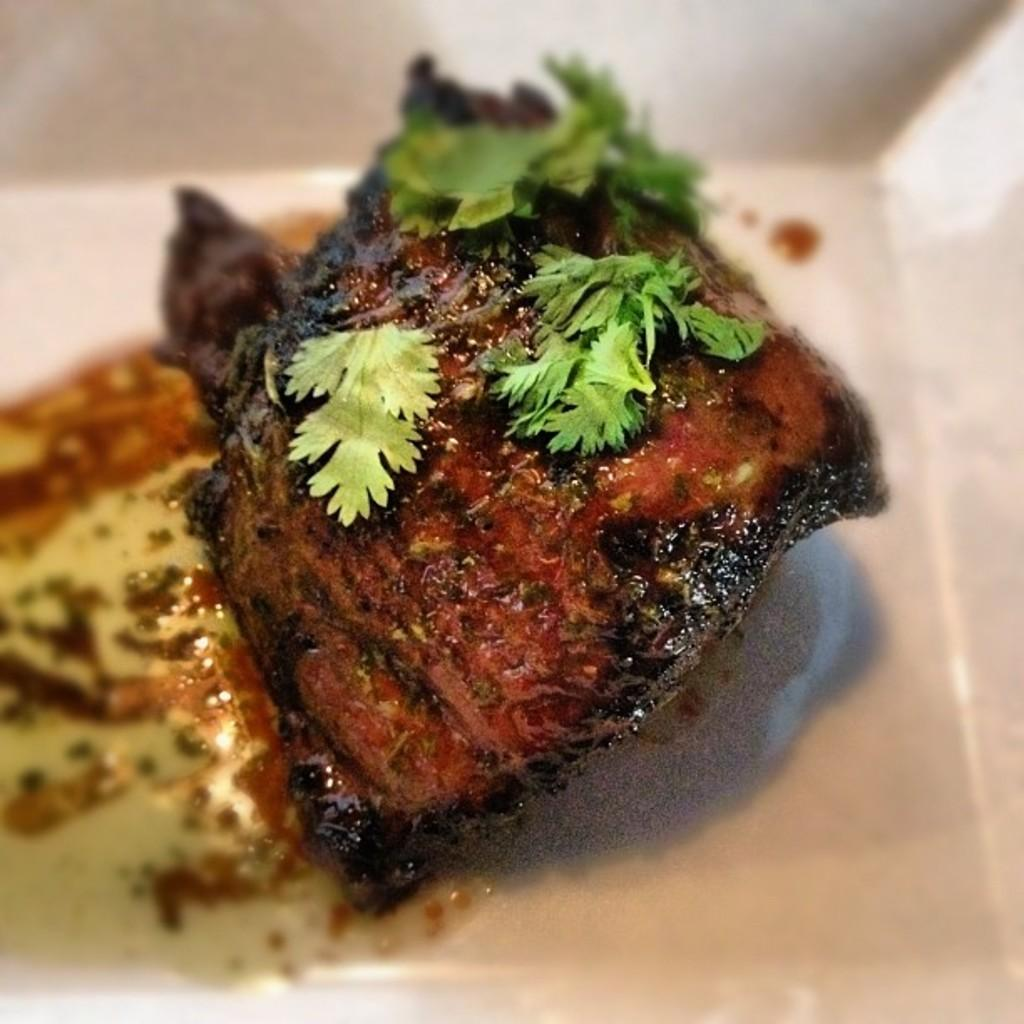What is the main subject of the image? The main subject of the image is food. Where is the food located in the image? The food is inside an object that looks like a bowl. What type of plot is being developed in the image? There is no plot present in the image, as it is a still image of food inside a bowl. Can you see any shoes in the image? There are no shoes visible in the image. 